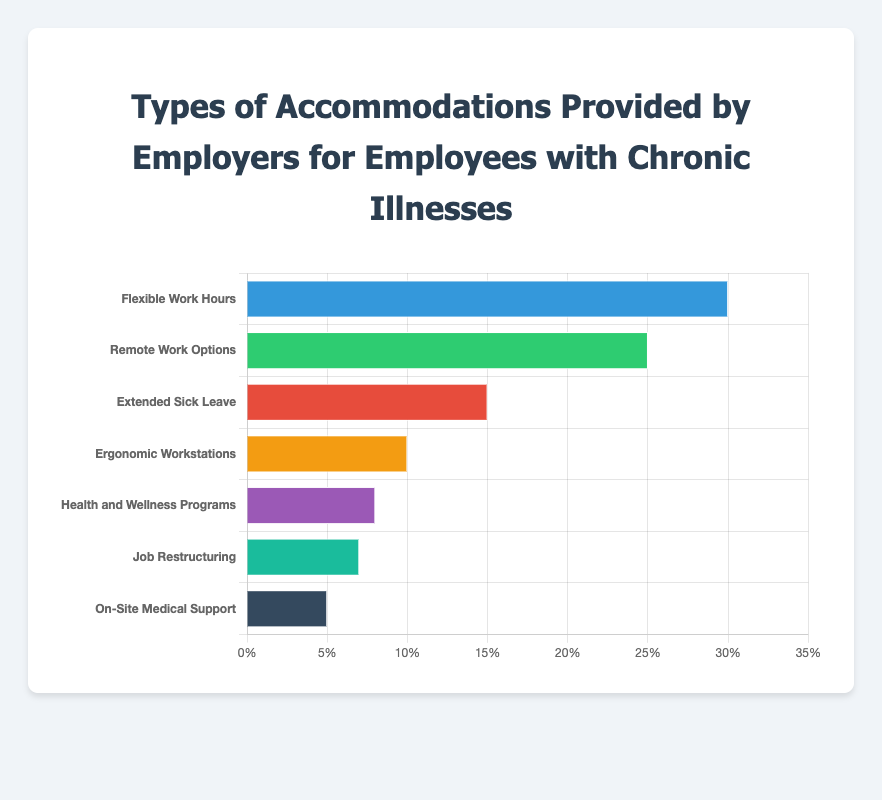What is the most common type of accommodation provided by employers for employees with chronic illnesses? The chart shows the percentage of employers offering each type of accommodation. The highest bar is for "Flexible Work Hours" at 30%.
Answer: Flexible Work Hours Which accommodation has a higher percentage: "Remote Work Options" or "Ergonomic Workstations"? By referring to the chart, we see that "Remote Work Options" has a bar with 25%, while "Ergonomic Workstations" has a bar with 10%.
Answer: Remote Work Options What is the combined percentage of employers providing "Extended Sick Leave" and "Health and Wellness Programs"? The percentage for "Extended Sick Leave" is 15% and for "Health and Wellness Programs" is 8%. Adding these together gives 15% + 8% = 23%.
Answer: 23% How does the percentage of "Job Restructuring" compare to "On-Site Medical Support"? "Job Restructuring" is at 7%, while "On-Site Medical Support" is at 5%. Therefore, the percentage for "Job Restructuring" is higher.
Answer: Higher Which accommodation has the smallest percentage of employers offering it? The chart shows that the shortest bar is for "On-Site Medical Support" with a percentage of 5%.
Answer: On-Site Medical Support How much more common is "Flexible Work Hours" compared to "Health and Wellness Programs"? "Flexible Work Hours" is provided by 30% of employers, while "Health and Wellness Programs" is provided by 8%. The difference is 30% - 8% = 22%.
Answer: 22% What is the average percentage of employers offering "Ergonomic Workstations" and "Job Restructuring"? "Ergonomic Workstations" is at 10% and "Job Restructuring" at 7%. The average is (10% + 7%) / 2 = 8.5%.
Answer: 8.5% Rank the accommodations from most to least common based on the percentage provided by employers. Arranging the accommodations from highest to lowest percentages according to the chart: Flexible Work Hours (30%), Remote Work Options (25%), Extended Sick Leave (15%), Ergonomic Workstations (10%), Health and Wellness Programs (8%), Job Restructuring (7%), On-Site Medical Support (5%).
Answer: Flexible Work Hours, Remote Work Options, Extended Sick Leave, Ergonomic Workstations, Health and Wellness Programs, Job Restructuring, On-Site Medical Support How do the top two accommodations compare in terms of percentage difference? The top two accommodations are "Flexible Work Hours" (30%) and "Remote Work Options" (25%). The difference is 30% - 25% = 5%.
Answer: 5% What is the median percentage of the provided accommodations? Listing the percentages in ascending order: 5%, 7%, 8%, 10%, 15%, 25%, 30%. The median is the middle value, which is 10%.
Answer: 10% 